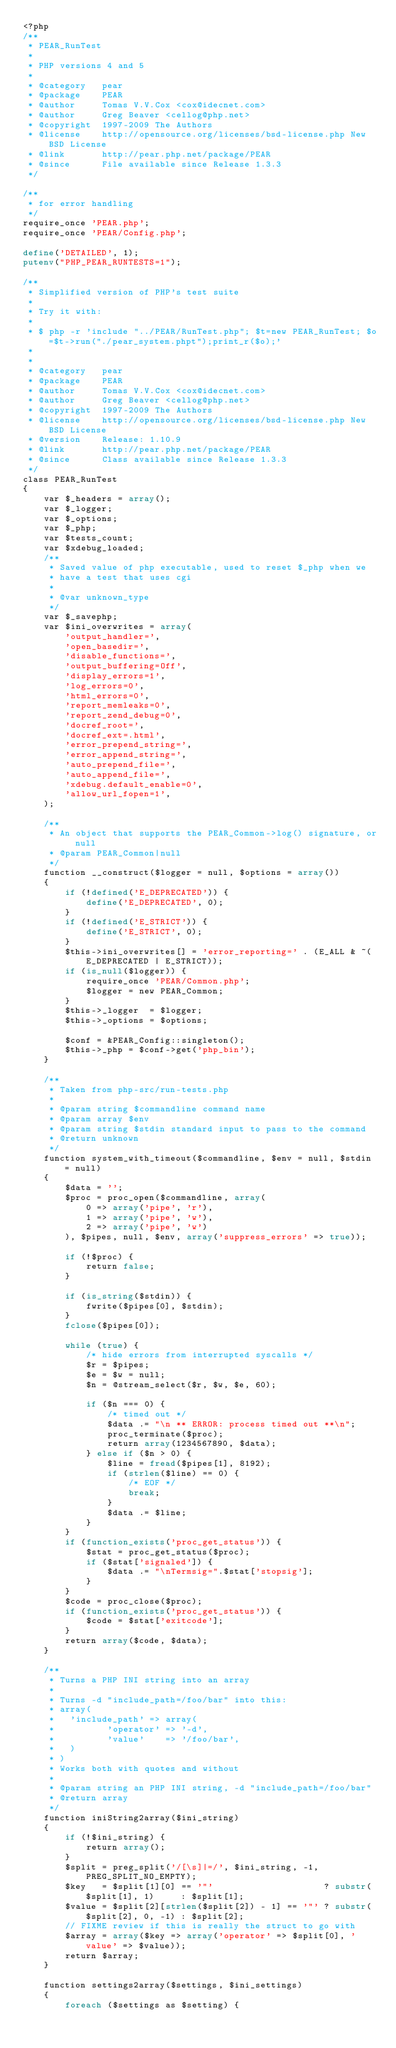<code> <loc_0><loc_0><loc_500><loc_500><_PHP_><?php
/**
 * PEAR_RunTest
 *
 * PHP versions 4 and 5
 *
 * @category   pear
 * @package    PEAR
 * @author     Tomas V.V.Cox <cox@idecnet.com>
 * @author     Greg Beaver <cellog@php.net>
 * @copyright  1997-2009 The Authors
 * @license    http://opensource.org/licenses/bsd-license.php New BSD License
 * @link       http://pear.php.net/package/PEAR
 * @since      File available since Release 1.3.3
 */

/**
 * for error handling
 */
require_once 'PEAR.php';
require_once 'PEAR/Config.php';

define('DETAILED', 1);
putenv("PHP_PEAR_RUNTESTS=1");

/**
 * Simplified version of PHP's test suite
 *
 * Try it with:
 *
 * $ php -r 'include "../PEAR/RunTest.php"; $t=new PEAR_RunTest; $o=$t->run("./pear_system.phpt");print_r($o);'
 *
 *
 * @category   pear
 * @package    PEAR
 * @author     Tomas V.V.Cox <cox@idecnet.com>
 * @author     Greg Beaver <cellog@php.net>
 * @copyright  1997-2009 The Authors
 * @license    http://opensource.org/licenses/bsd-license.php New BSD License
 * @version    Release: 1.10.9
 * @link       http://pear.php.net/package/PEAR
 * @since      Class available since Release 1.3.3
 */
class PEAR_RunTest
{
    var $_headers = array();
    var $_logger;
    var $_options;
    var $_php;
    var $tests_count;
    var $xdebug_loaded;
    /**
     * Saved value of php executable, used to reset $_php when we
     * have a test that uses cgi
     *
     * @var unknown_type
     */
    var $_savephp;
    var $ini_overwrites = array(
        'output_handler=',
        'open_basedir=',
        'disable_functions=',
        'output_buffering=Off',
        'display_errors=1',
        'log_errors=0',
        'html_errors=0',
        'report_memleaks=0',
        'report_zend_debug=0',
        'docref_root=',
        'docref_ext=.html',
        'error_prepend_string=',
        'error_append_string=',
        'auto_prepend_file=',
        'auto_append_file=',
        'xdebug.default_enable=0',
        'allow_url_fopen=1',
    );

    /**
     * An object that supports the PEAR_Common->log() signature, or null
     * @param PEAR_Common|null
     */
    function __construct($logger = null, $options = array())
    {
        if (!defined('E_DEPRECATED')) {
            define('E_DEPRECATED', 0);
        }
        if (!defined('E_STRICT')) {
            define('E_STRICT', 0);
        }
        $this->ini_overwrites[] = 'error_reporting=' . (E_ALL & ~(E_DEPRECATED | E_STRICT));
        if (is_null($logger)) {
            require_once 'PEAR/Common.php';
            $logger = new PEAR_Common;
        }
        $this->_logger  = $logger;
        $this->_options = $options;

        $conf = &PEAR_Config::singleton();
        $this->_php = $conf->get('php_bin');
    }

    /**
     * Taken from php-src/run-tests.php
     *
     * @param string $commandline command name
     * @param array $env
     * @param string $stdin standard input to pass to the command
     * @return unknown
     */
    function system_with_timeout($commandline, $env = null, $stdin = null)
    {
        $data = '';
        $proc = proc_open($commandline, array(
            0 => array('pipe', 'r'),
            1 => array('pipe', 'w'),
            2 => array('pipe', 'w')
        ), $pipes, null, $env, array('suppress_errors' => true));

        if (!$proc) {
            return false;
        }

        if (is_string($stdin)) {
            fwrite($pipes[0], $stdin);
        }
        fclose($pipes[0]);

        while (true) {
            /* hide errors from interrupted syscalls */
            $r = $pipes;
            $e = $w = null;
            $n = @stream_select($r, $w, $e, 60);

            if ($n === 0) {
                /* timed out */
                $data .= "\n ** ERROR: process timed out **\n";
                proc_terminate($proc);
                return array(1234567890, $data);
            } else if ($n > 0) {
                $line = fread($pipes[1], 8192);
                if (strlen($line) == 0) {
                    /* EOF */
                    break;
                }
                $data .= $line;
            }
        }
        if (function_exists('proc_get_status')) {
            $stat = proc_get_status($proc);
            if ($stat['signaled']) {
                $data .= "\nTermsig=".$stat['stopsig'];
            }
        }
        $code = proc_close($proc);
        if (function_exists('proc_get_status')) {
            $code = $stat['exitcode'];
        }
        return array($code, $data);
    }

    /**
     * Turns a PHP INI string into an array
     *
     * Turns -d "include_path=/foo/bar" into this:
     * array(
     *   'include_path' => array(
     *          'operator' => '-d',
     *          'value'    => '/foo/bar',
     *   )
     * )
     * Works both with quotes and without
     *
     * @param string an PHP INI string, -d "include_path=/foo/bar"
     * @return array
     */
    function iniString2array($ini_string)
    {
        if (!$ini_string) {
            return array();
        }
        $split = preg_split('/[\s]|=/', $ini_string, -1, PREG_SPLIT_NO_EMPTY);
        $key   = $split[1][0] == '"'                     ? substr($split[1], 1)     : $split[1];
        $value = $split[2][strlen($split[2]) - 1] == '"' ? substr($split[2], 0, -1) : $split[2];
        // FIXME review if this is really the struct to go with
        $array = array($key => array('operator' => $split[0], 'value' => $value));
        return $array;
    }

    function settings2array($settings, $ini_settings)
    {
        foreach ($settings as $setting) {</code> 